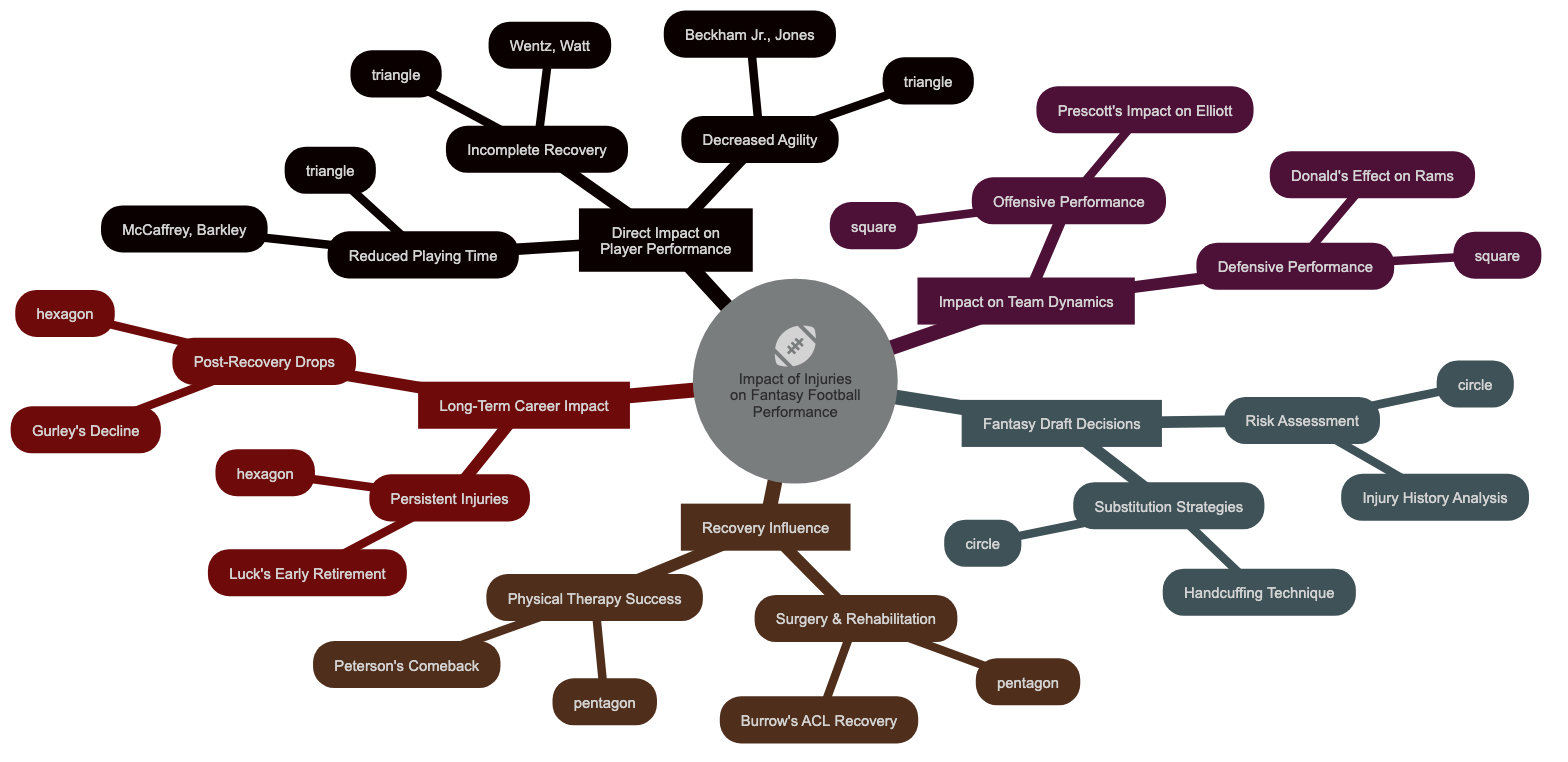What are the two impacts listed under Direct Impact on Player Performance? The diagram specifies three impacts: Reduced Playing Time, Decreased Physical Agility, and Incomplete Recovery. The first two are what were asked, so counting them gives us: Reduced Playing Time and Decreased Agility.
Answer: Reduced Playing Time, Decreased Agility How many players are listed under Incomplete Recovery? The Incomplete Recovery node lists two players: Carson Wentz and T.J. Watt. The total is counted by identifying the names under that specific impact.
Answer: 2 Which player is associated with decreased physical agility? The Decreased Physical Agility node indicates two players: Odell Beckham Jr. and Julio Jones. The question specifically asks for one, and either can be selected.
Answer: Odell Beckham Jr What is the relationship between Dak Prescott's absence and Ezekiel Elliott? The diagram indicates that Dak Prescott's absence negatively impacts Ezekiel Elliott's performance as seen in the Offensive Performance section under Impact on Team Dynamics. Therefore, their relationship is based on performance impact.
Answer: Negative impact Which two aspects are covered under Recovery Influence? The Recovery Influence node includes two specific aspects: Impact of Surgery and Rehabilitation, and Physical Therapy Success Stories. We can identify them clearly by counting the branches located under that node.
Answer: Impact of Surgery and Rehabilitation, Physical Therapy Success Which two players are mentioned in the context of persistent injuries? The Long-Term Career Impact node lists Andrew Luck and Cam Newton under Persistent Injuries, highlighting their situations directly tied to injury issues.
Answer: Andrew Luck, Cam Newton How many strategies are mentioned under Substitution Strategies? There are two strategies listed under Substitution Strategies: Handcuffing Technique and Waiver Wire Replacements. Counting them gives the answer.
Answer: 2 In which category is Adrian Peterson mentioned? The diagram places Adrian Peterson under the Recovery Influence category, specifically in Physical Therapy Success Stories. This categorization can be identified by tracing the nodes leading to his name.
Answer: Recovery Influence What is one specific example of a post-recovery performance drop? The diagram provides Todd Gurley's Decline as a specific example under the Post-Recovery Performance Drops. Thus, this is a concrete case cited explicitly in that area of the map.
Answer: Todd Gurley's Decline 